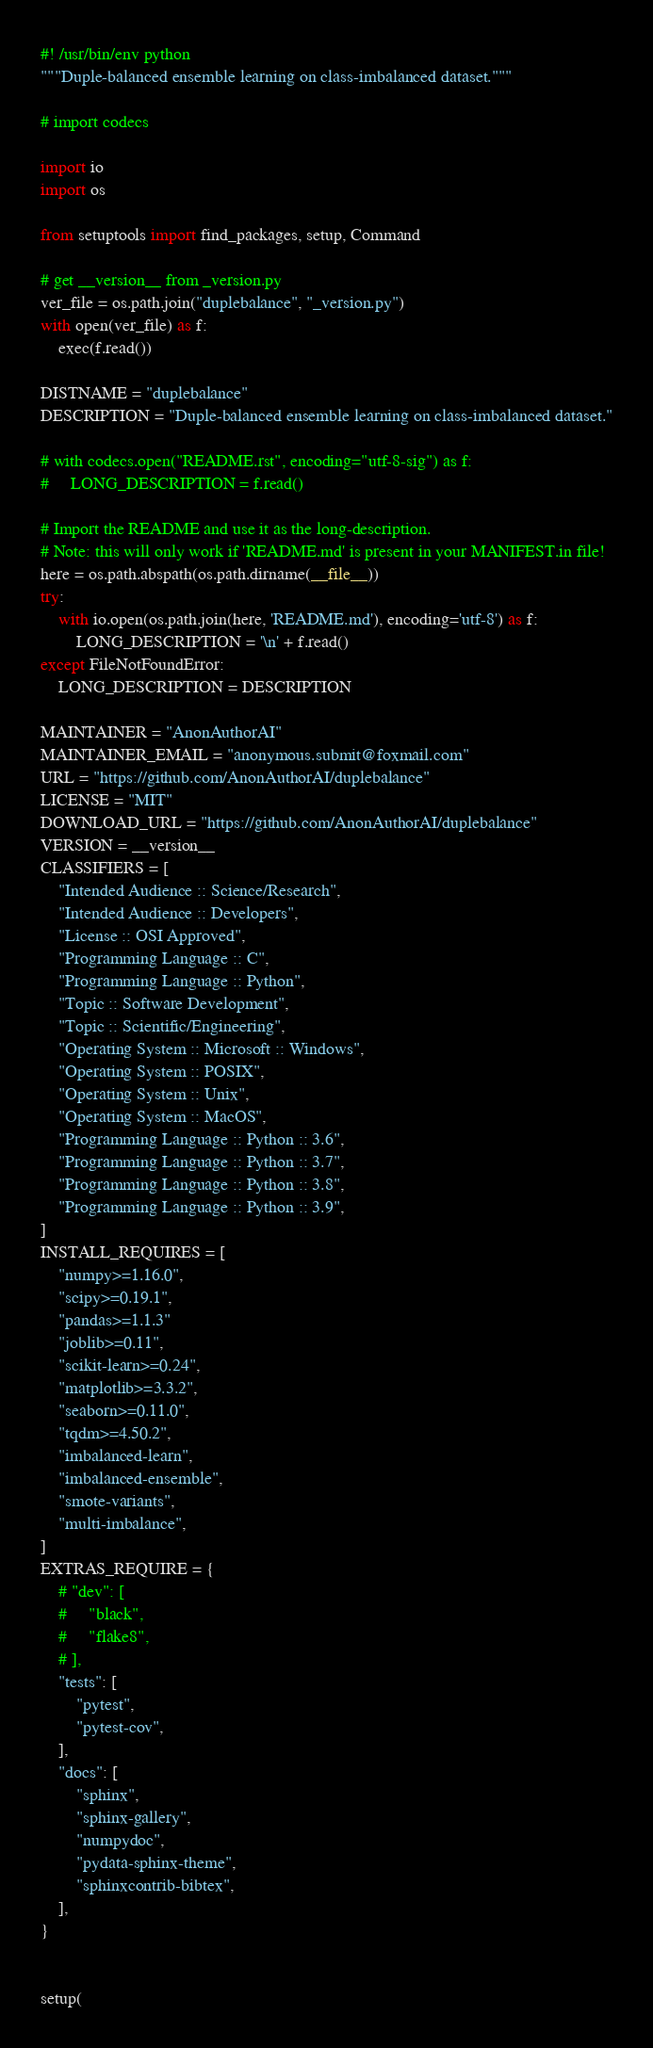<code> <loc_0><loc_0><loc_500><loc_500><_Python_>#! /usr/bin/env python
"""Duple-balanced ensemble learning on class-imbalanced dataset."""

# import codecs

import io
import os

from setuptools import find_packages, setup, Command

# get __version__ from _version.py
ver_file = os.path.join("duplebalance", "_version.py")
with open(ver_file) as f:
    exec(f.read())

DISTNAME = "duplebalance"
DESCRIPTION = "Duple-balanced ensemble learning on class-imbalanced dataset."

# with codecs.open("README.rst", encoding="utf-8-sig") as f:
#     LONG_DESCRIPTION = f.read()

# Import the README and use it as the long-description.
# Note: this will only work if 'README.md' is present in your MANIFEST.in file!
here = os.path.abspath(os.path.dirname(__file__))
try:
    with io.open(os.path.join(here, 'README.md'), encoding='utf-8') as f:
        LONG_DESCRIPTION = '\n' + f.read()
except FileNotFoundError:
    LONG_DESCRIPTION = DESCRIPTION

MAINTAINER = "AnonAuthorAI"
MAINTAINER_EMAIL = "anonymous.submit@foxmail.com"
URL = "https://github.com/AnonAuthorAI/duplebalance"
LICENSE = "MIT"
DOWNLOAD_URL = "https://github.com/AnonAuthorAI/duplebalance"
VERSION = __version__
CLASSIFIERS = [
    "Intended Audience :: Science/Research",
    "Intended Audience :: Developers",
    "License :: OSI Approved",
    "Programming Language :: C",
    "Programming Language :: Python",
    "Topic :: Software Development",
    "Topic :: Scientific/Engineering",
    "Operating System :: Microsoft :: Windows",
    "Operating System :: POSIX",
    "Operating System :: Unix",
    "Operating System :: MacOS",
    "Programming Language :: Python :: 3.6",
    "Programming Language :: Python :: 3.7",
    "Programming Language :: Python :: 3.8",
    "Programming Language :: Python :: 3.9",
]
INSTALL_REQUIRES = [
    "numpy>=1.16.0",
    "scipy>=0.19.1",
    "pandas>=1.1.3"
    "joblib>=0.11",
    "scikit-learn>=0.24",
    "matplotlib>=3.3.2",
    "seaborn>=0.11.0",
    "tqdm>=4.50.2",
    "imbalanced-learn",
    "imbalanced-ensemble",
    "smote-variants",
    "multi-imbalance",
]
EXTRAS_REQUIRE = {
    # "dev": [
    #     "black",
    #     "flake8",
    # ],
    "tests": [
        "pytest",
        "pytest-cov",
    ],
    "docs": [
        "sphinx",
        "sphinx-gallery",
        "numpydoc",
        "pydata-sphinx-theme",
        "sphinxcontrib-bibtex",
    ],
}


setup(</code> 